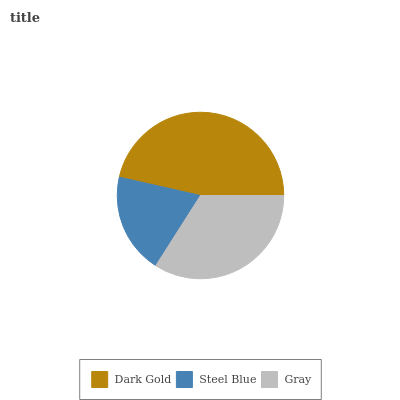Is Steel Blue the minimum?
Answer yes or no. Yes. Is Dark Gold the maximum?
Answer yes or no. Yes. Is Gray the minimum?
Answer yes or no. No. Is Gray the maximum?
Answer yes or no. No. Is Gray greater than Steel Blue?
Answer yes or no. Yes. Is Steel Blue less than Gray?
Answer yes or no. Yes. Is Steel Blue greater than Gray?
Answer yes or no. No. Is Gray less than Steel Blue?
Answer yes or no. No. Is Gray the high median?
Answer yes or no. Yes. Is Gray the low median?
Answer yes or no. Yes. Is Steel Blue the high median?
Answer yes or no. No. Is Dark Gold the low median?
Answer yes or no. No. 